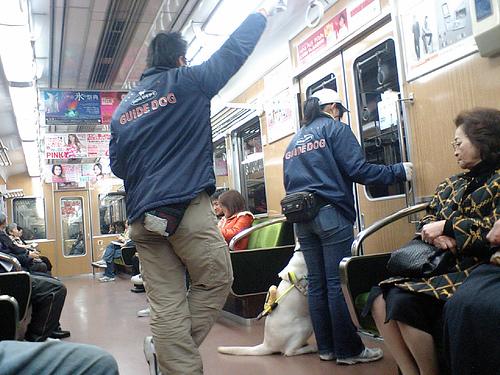What words are printed on the man's coat?
Write a very short answer. Guide dog. Can the dog open the door?
Concise answer only. No. What special training is the dog receiving?
Give a very brief answer. Guide dog. 